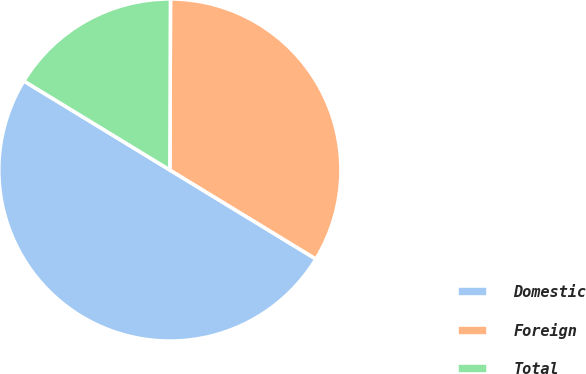Convert chart to OTSL. <chart><loc_0><loc_0><loc_500><loc_500><pie_chart><fcel>Domestic<fcel>Foreign<fcel>Total<nl><fcel>50.0%<fcel>33.66%<fcel>16.34%<nl></chart> 